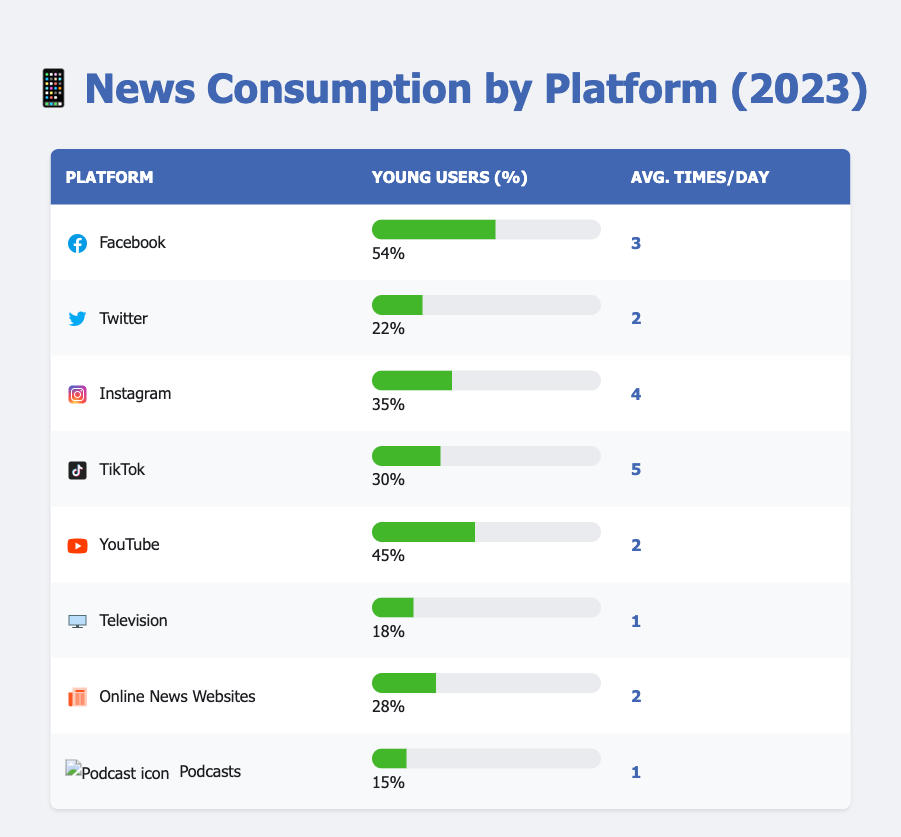What percentage of young users consume news from Instagram? According to the table, Instagram has a specific row that illustrates the percentage of young users consuming news through this platform, which is 35%.
Answer: 35% Which platform has the highest average times per day for news consumption among young users? By checking the average times per day column, TikTok has the highest value at 5 times per day compared to the other platforms listed.
Answer: TikTok Is it true that fewer young users consume news through television compared to Twitter? The table shows that 18% of young users consume news through television, while 22% do so through Twitter. Since 18% is less than 22%, the statement is true.
Answer: Yes What is the total percentage of young users who consume news through social media platforms listed in the table? Adding the percentages for Facebook (54%), Twitter (22%), Instagram (35%), TikTok (30%), and YouTube (45%) gives a total of 54 + 22 + 35 + 30 + 45 = 186%.
Answer: 186% How does the average number of times per day for news consumption on Facebook compare to that on YouTube? Facebook has an average of 3 times per day, while YouTube has an average of 2 times per day. Since 3 is greater than 2, Facebook has a higher average.
Answer: Facebook has a higher average Which two platforms have an equal average number of times per day for news consumption? The table shows that both Twitter and Online News Websites have an average of 2 times per day. Thus, these two platforms match in that statistic.
Answer: Twitter and Online News Websites What percentage of young users consume news through podcasts? Referring to the table, it indicates that 15% of young users consume news through podcasts.
Answer: 15% Which platform has the lowest percentage of young news consumers? Looking at the percentage column, podcasts have the lowest percentage at 15%, making them the least consumed platform for news among young users.
Answer: Podcasts 